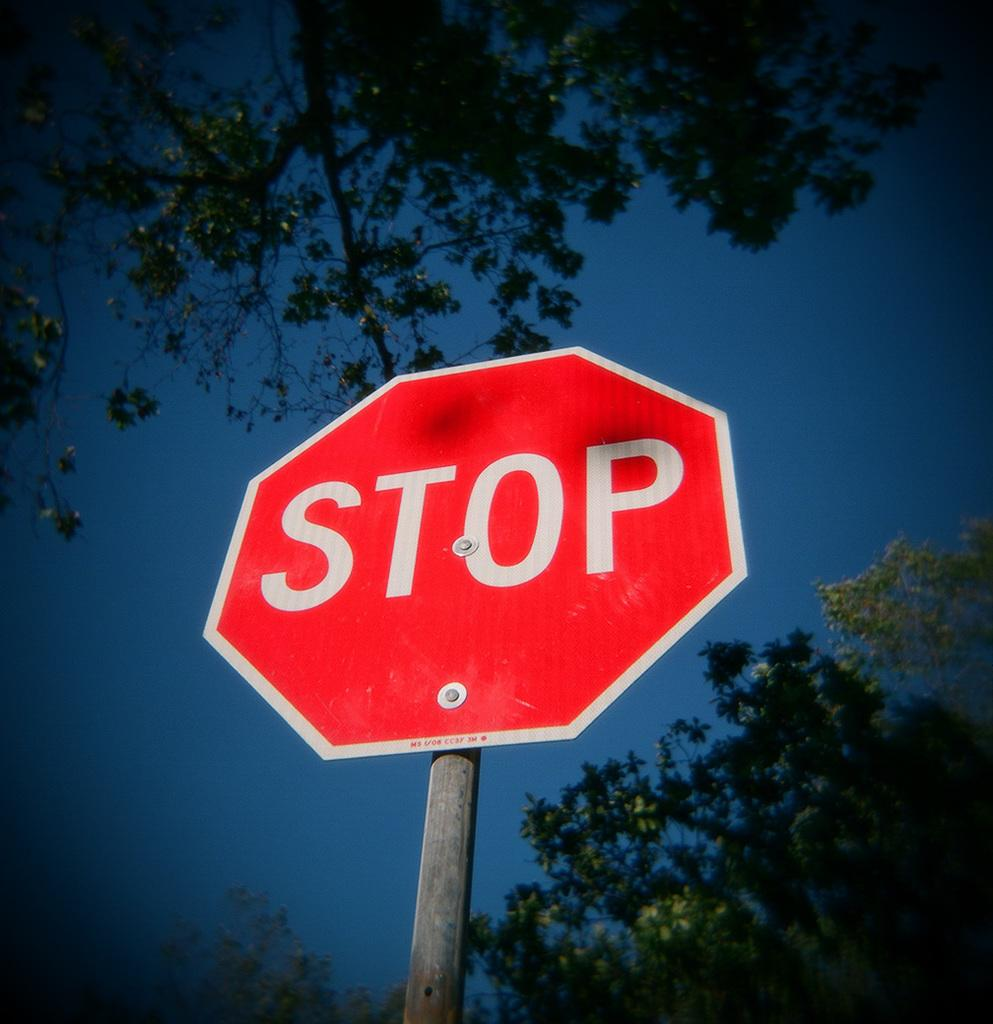<image>
Summarize the visual content of the image. a stop sign that has some trees around it 